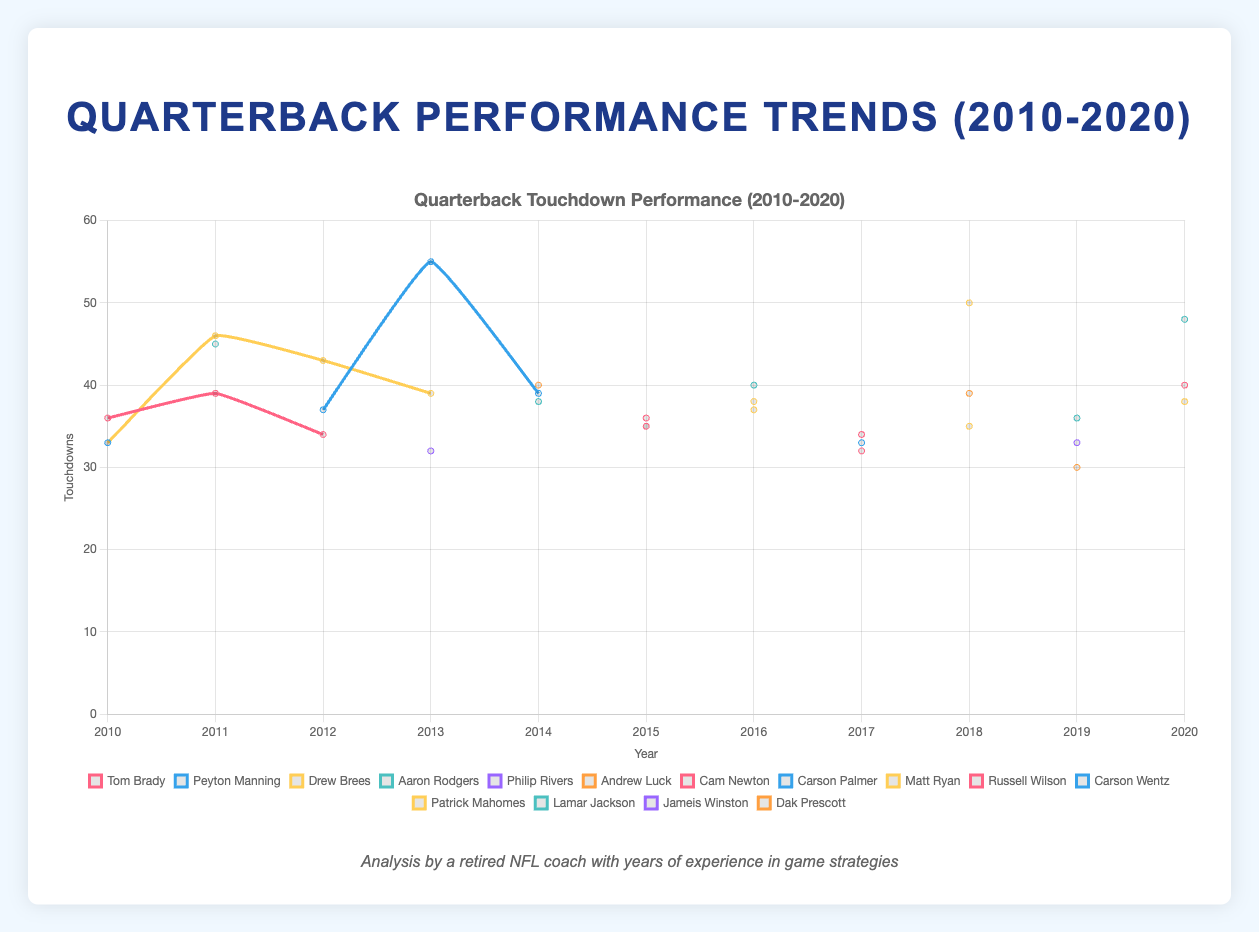What was the highest number of touchdowns in 2013 and which quarterback achieved it? Looking at the touchdowns in 2013, Peyton Manning has the highest number with 55 touchdowns. This can be confirmed by checking the line plot and identifying the peak value for the year 2013 matched with the quarterback’s name.
Answer: 55, Peyton Manning Between 2010 and 2020, which quarterback had the most consistent pass completion rate? Consistency in pass completion rate can be observed by minimal fluctuations in the plotted line for each quarterback over the years. Aaron Rodgers's line appears the most stable and remains consistently high without major drops or spikes.
Answer: Aaron Rodgers Compare the touchdowns of Aaron Rodgers in 2011 and 2020. What is the difference and which year was higher? In 2011, Aaron Rodgers had 45 touchdowns. In 2020, he had 48 touchdowns. To find the difference, subtract 45 from 48. The year 2020 was higher by 3 touchdowns.
Answer: 3, 2020 Who had the highest pass completion rate in 2016 and what was the rate? The plot of pass completion rates will show 2016, where Drew Brees has the highest with a rate of 70.0%.
Answer: Drew Brees, 70.0% Which quarterback had the highest number of interceptions in 2010? By looking at the interceptions figure for 2010, Drew Brees had the highest number with 22 interceptions.
Answer: Drew Brees In 2012, who had more interceptions: Tom Brady or Peyton Manning, and how many more? Checking the interceptions data for 2012 for both quarterbacks, Tom Brady had 8 and Peyton Manning had 11. Peyton Manning had 3 more interceptions than Tom Brady.
Answer: Peyton Manning, 3 How do the touchdown counts of Tom Brady and Patrick Mahomes compare in 2020? For 2020, Tom Brady had 40 touchdowns while Patrick Mahomes had 38. Tom Brady had 2 more touchdowns than Patrick Mahomes.
Answer: Tom Brady, 2 What is the trend in pass completion rates for Drew Brees from 2010 to 2013? Analyzing the plot points for Drew Brees in these years, his pass completion rates were 68.1% (2010), 71.2% (2011), 63.0% (2012), and 68.6% (2013). The trend shows a rise from 2010 to 2011, a drop in 2012, and a rise again in 2013, indicating fluctuations over the years.
Answer: Fluctuating Which year did Tom Brady achieve his highest number of touchdowns and how many were they? Reviewing Tom Brady's touchdown data over the decade, his highest number of touchdowns was 40 in 2020.
Answer: 2020, 40 From 2015 to 2017, what is the average pass completion rate for Tom Brady? To find the average pass completion rate, sum the rates for these years: 64.4% (2015), 66.3% (2017) and divide by 2 (note he was not a top QB in 2016): (64.4% + 66.3%) / 2 = 65.35%.
Answer: 65.35% 